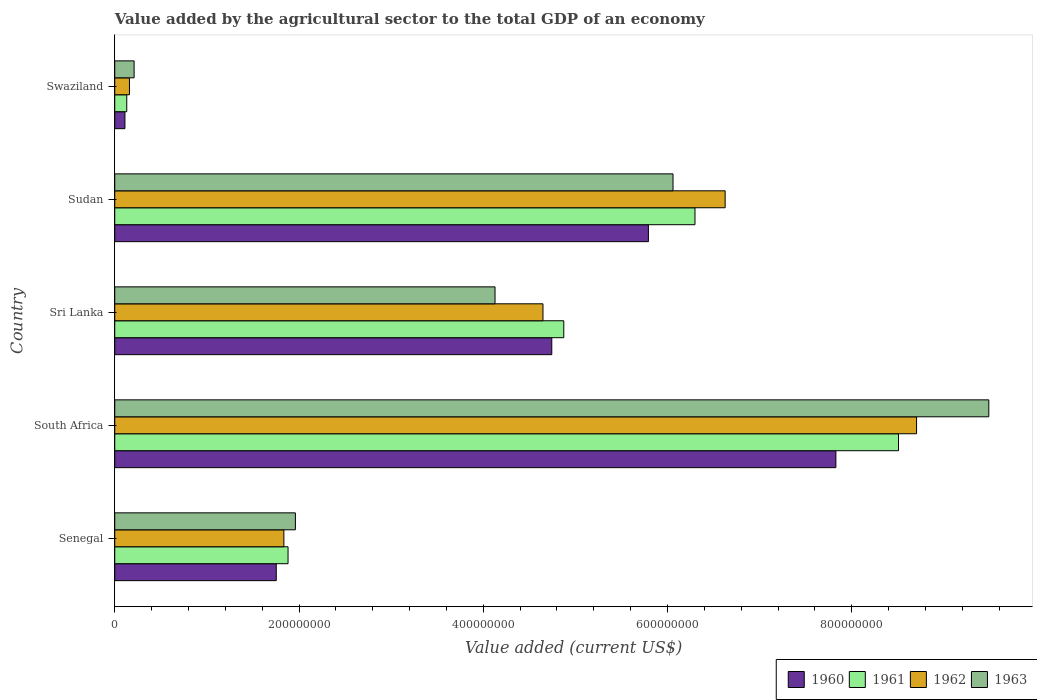How many different coloured bars are there?
Ensure brevity in your answer.  4. How many groups of bars are there?
Offer a terse response. 5. How many bars are there on the 4th tick from the top?
Provide a succinct answer. 4. How many bars are there on the 3rd tick from the bottom?
Your answer should be compact. 4. What is the label of the 5th group of bars from the top?
Keep it short and to the point. Senegal. What is the value added by the agricultural sector to the total GDP in 1963 in Sudan?
Your answer should be compact. 6.06e+08. Across all countries, what is the maximum value added by the agricultural sector to the total GDP in 1960?
Your answer should be very brief. 7.83e+08. Across all countries, what is the minimum value added by the agricultural sector to the total GDP in 1961?
Provide a short and direct response. 1.30e+07. In which country was the value added by the agricultural sector to the total GDP in 1960 maximum?
Your answer should be very brief. South Africa. In which country was the value added by the agricultural sector to the total GDP in 1961 minimum?
Your answer should be compact. Swaziland. What is the total value added by the agricultural sector to the total GDP in 1960 in the graph?
Provide a succinct answer. 2.02e+09. What is the difference between the value added by the agricultural sector to the total GDP in 1962 in Senegal and that in Sri Lanka?
Provide a short and direct response. -2.81e+08. What is the difference between the value added by the agricultural sector to the total GDP in 1962 in Swaziland and the value added by the agricultural sector to the total GDP in 1963 in South Africa?
Ensure brevity in your answer.  -9.33e+08. What is the average value added by the agricultural sector to the total GDP in 1961 per country?
Give a very brief answer. 4.34e+08. What is the difference between the value added by the agricultural sector to the total GDP in 1963 and value added by the agricultural sector to the total GDP in 1961 in Swaziland?
Provide a succinct answer. 7.98e+06. What is the ratio of the value added by the agricultural sector to the total GDP in 1960 in Senegal to that in Swaziland?
Your answer should be very brief. 15.85. Is the difference between the value added by the agricultural sector to the total GDP in 1963 in South Africa and Sudan greater than the difference between the value added by the agricultural sector to the total GDP in 1961 in South Africa and Sudan?
Give a very brief answer. Yes. What is the difference between the highest and the second highest value added by the agricultural sector to the total GDP in 1960?
Your response must be concise. 2.04e+08. What is the difference between the highest and the lowest value added by the agricultural sector to the total GDP in 1960?
Offer a terse response. 7.72e+08. Is it the case that in every country, the sum of the value added by the agricultural sector to the total GDP in 1963 and value added by the agricultural sector to the total GDP in 1960 is greater than the sum of value added by the agricultural sector to the total GDP in 1962 and value added by the agricultural sector to the total GDP in 1961?
Your answer should be compact. No. Are all the bars in the graph horizontal?
Your answer should be very brief. Yes. How many countries are there in the graph?
Your answer should be very brief. 5. Does the graph contain any zero values?
Your answer should be very brief. No. Does the graph contain grids?
Your answer should be compact. No. Where does the legend appear in the graph?
Your answer should be very brief. Bottom right. How are the legend labels stacked?
Your answer should be compact. Horizontal. What is the title of the graph?
Provide a succinct answer. Value added by the agricultural sector to the total GDP of an economy. What is the label or title of the X-axis?
Keep it short and to the point. Value added (current US$). What is the label or title of the Y-axis?
Make the answer very short. Country. What is the Value added (current US$) of 1960 in Senegal?
Ensure brevity in your answer.  1.75e+08. What is the Value added (current US$) in 1961 in Senegal?
Offer a very short reply. 1.88e+08. What is the Value added (current US$) of 1962 in Senegal?
Your response must be concise. 1.84e+08. What is the Value added (current US$) in 1963 in Senegal?
Keep it short and to the point. 1.96e+08. What is the Value added (current US$) in 1960 in South Africa?
Your response must be concise. 7.83e+08. What is the Value added (current US$) in 1961 in South Africa?
Your answer should be compact. 8.51e+08. What is the Value added (current US$) in 1962 in South Africa?
Offer a terse response. 8.70e+08. What is the Value added (current US$) in 1963 in South Africa?
Your answer should be very brief. 9.49e+08. What is the Value added (current US$) in 1960 in Sri Lanka?
Provide a short and direct response. 4.74e+08. What is the Value added (current US$) in 1961 in Sri Lanka?
Your answer should be compact. 4.87e+08. What is the Value added (current US$) of 1962 in Sri Lanka?
Offer a terse response. 4.65e+08. What is the Value added (current US$) in 1963 in Sri Lanka?
Your answer should be compact. 4.13e+08. What is the Value added (current US$) in 1960 in Sudan?
Make the answer very short. 5.79e+08. What is the Value added (current US$) in 1961 in Sudan?
Your answer should be very brief. 6.30e+08. What is the Value added (current US$) in 1962 in Sudan?
Offer a terse response. 6.63e+08. What is the Value added (current US$) of 1963 in Sudan?
Make the answer very short. 6.06e+08. What is the Value added (current US$) of 1960 in Swaziland?
Your response must be concise. 1.11e+07. What is the Value added (current US$) of 1961 in Swaziland?
Provide a succinct answer. 1.30e+07. What is the Value added (current US$) of 1962 in Swaziland?
Offer a terse response. 1.60e+07. What is the Value added (current US$) of 1963 in Swaziland?
Give a very brief answer. 2.10e+07. Across all countries, what is the maximum Value added (current US$) in 1960?
Offer a terse response. 7.83e+08. Across all countries, what is the maximum Value added (current US$) in 1961?
Provide a short and direct response. 8.51e+08. Across all countries, what is the maximum Value added (current US$) of 1962?
Offer a terse response. 8.70e+08. Across all countries, what is the maximum Value added (current US$) of 1963?
Your answer should be compact. 9.49e+08. Across all countries, what is the minimum Value added (current US$) of 1960?
Your response must be concise. 1.11e+07. Across all countries, what is the minimum Value added (current US$) of 1961?
Keep it short and to the point. 1.30e+07. Across all countries, what is the minimum Value added (current US$) of 1962?
Offer a terse response. 1.60e+07. Across all countries, what is the minimum Value added (current US$) of 1963?
Ensure brevity in your answer.  2.10e+07. What is the total Value added (current US$) in 1960 in the graph?
Offer a very short reply. 2.02e+09. What is the total Value added (current US$) of 1961 in the graph?
Provide a short and direct response. 2.17e+09. What is the total Value added (current US$) in 1962 in the graph?
Your response must be concise. 2.20e+09. What is the total Value added (current US$) in 1963 in the graph?
Your answer should be very brief. 2.18e+09. What is the difference between the Value added (current US$) of 1960 in Senegal and that in South Africa?
Your answer should be compact. -6.07e+08. What is the difference between the Value added (current US$) in 1961 in Senegal and that in South Africa?
Offer a terse response. -6.63e+08. What is the difference between the Value added (current US$) in 1962 in Senegal and that in South Africa?
Your response must be concise. -6.87e+08. What is the difference between the Value added (current US$) of 1963 in Senegal and that in South Africa?
Make the answer very short. -7.53e+08. What is the difference between the Value added (current US$) of 1960 in Senegal and that in Sri Lanka?
Give a very brief answer. -2.99e+08. What is the difference between the Value added (current US$) of 1961 in Senegal and that in Sri Lanka?
Your response must be concise. -2.99e+08. What is the difference between the Value added (current US$) in 1962 in Senegal and that in Sri Lanka?
Your response must be concise. -2.81e+08. What is the difference between the Value added (current US$) in 1963 in Senegal and that in Sri Lanka?
Provide a succinct answer. -2.17e+08. What is the difference between the Value added (current US$) in 1960 in Senegal and that in Sudan?
Offer a terse response. -4.04e+08. What is the difference between the Value added (current US$) of 1961 in Senegal and that in Sudan?
Your answer should be compact. -4.42e+08. What is the difference between the Value added (current US$) of 1962 in Senegal and that in Sudan?
Provide a succinct answer. -4.79e+08. What is the difference between the Value added (current US$) of 1963 in Senegal and that in Sudan?
Offer a terse response. -4.10e+08. What is the difference between the Value added (current US$) of 1960 in Senegal and that in Swaziland?
Give a very brief answer. 1.64e+08. What is the difference between the Value added (current US$) of 1961 in Senegal and that in Swaziland?
Offer a very short reply. 1.75e+08. What is the difference between the Value added (current US$) in 1962 in Senegal and that in Swaziland?
Make the answer very short. 1.68e+08. What is the difference between the Value added (current US$) of 1963 in Senegal and that in Swaziland?
Provide a succinct answer. 1.75e+08. What is the difference between the Value added (current US$) in 1960 in South Africa and that in Sri Lanka?
Your answer should be very brief. 3.08e+08. What is the difference between the Value added (current US$) of 1961 in South Africa and that in Sri Lanka?
Your answer should be very brief. 3.63e+08. What is the difference between the Value added (current US$) of 1962 in South Africa and that in Sri Lanka?
Your answer should be compact. 4.06e+08. What is the difference between the Value added (current US$) in 1963 in South Africa and that in Sri Lanka?
Provide a short and direct response. 5.36e+08. What is the difference between the Value added (current US$) of 1960 in South Africa and that in Sudan?
Keep it short and to the point. 2.04e+08. What is the difference between the Value added (current US$) in 1961 in South Africa and that in Sudan?
Your response must be concise. 2.21e+08. What is the difference between the Value added (current US$) in 1962 in South Africa and that in Sudan?
Your answer should be compact. 2.08e+08. What is the difference between the Value added (current US$) in 1963 in South Africa and that in Sudan?
Provide a succinct answer. 3.43e+08. What is the difference between the Value added (current US$) in 1960 in South Africa and that in Swaziland?
Keep it short and to the point. 7.72e+08. What is the difference between the Value added (current US$) of 1961 in South Africa and that in Swaziland?
Keep it short and to the point. 8.38e+08. What is the difference between the Value added (current US$) in 1962 in South Africa and that in Swaziland?
Ensure brevity in your answer.  8.54e+08. What is the difference between the Value added (current US$) in 1963 in South Africa and that in Swaziland?
Offer a very short reply. 9.28e+08. What is the difference between the Value added (current US$) in 1960 in Sri Lanka and that in Sudan?
Make the answer very short. -1.05e+08. What is the difference between the Value added (current US$) of 1961 in Sri Lanka and that in Sudan?
Offer a very short reply. -1.42e+08. What is the difference between the Value added (current US$) of 1962 in Sri Lanka and that in Sudan?
Provide a short and direct response. -1.98e+08. What is the difference between the Value added (current US$) in 1963 in Sri Lanka and that in Sudan?
Give a very brief answer. -1.93e+08. What is the difference between the Value added (current US$) of 1960 in Sri Lanka and that in Swaziland?
Your response must be concise. 4.63e+08. What is the difference between the Value added (current US$) in 1961 in Sri Lanka and that in Swaziland?
Your answer should be compact. 4.74e+08. What is the difference between the Value added (current US$) of 1962 in Sri Lanka and that in Swaziland?
Give a very brief answer. 4.49e+08. What is the difference between the Value added (current US$) in 1963 in Sri Lanka and that in Swaziland?
Provide a succinct answer. 3.92e+08. What is the difference between the Value added (current US$) in 1960 in Sudan and that in Swaziland?
Give a very brief answer. 5.68e+08. What is the difference between the Value added (current US$) in 1961 in Sudan and that in Swaziland?
Keep it short and to the point. 6.17e+08. What is the difference between the Value added (current US$) of 1962 in Sudan and that in Swaziland?
Provide a short and direct response. 6.47e+08. What is the difference between the Value added (current US$) in 1963 in Sudan and that in Swaziland?
Your answer should be compact. 5.85e+08. What is the difference between the Value added (current US$) in 1960 in Senegal and the Value added (current US$) in 1961 in South Africa?
Provide a short and direct response. -6.75e+08. What is the difference between the Value added (current US$) of 1960 in Senegal and the Value added (current US$) of 1962 in South Africa?
Keep it short and to the point. -6.95e+08. What is the difference between the Value added (current US$) of 1960 in Senegal and the Value added (current US$) of 1963 in South Africa?
Your answer should be compact. -7.73e+08. What is the difference between the Value added (current US$) in 1961 in Senegal and the Value added (current US$) in 1962 in South Africa?
Provide a short and direct response. -6.82e+08. What is the difference between the Value added (current US$) of 1961 in Senegal and the Value added (current US$) of 1963 in South Africa?
Ensure brevity in your answer.  -7.61e+08. What is the difference between the Value added (current US$) in 1962 in Senegal and the Value added (current US$) in 1963 in South Africa?
Offer a very short reply. -7.65e+08. What is the difference between the Value added (current US$) of 1960 in Senegal and the Value added (current US$) of 1961 in Sri Lanka?
Make the answer very short. -3.12e+08. What is the difference between the Value added (current US$) of 1960 in Senegal and the Value added (current US$) of 1962 in Sri Lanka?
Your response must be concise. -2.89e+08. What is the difference between the Value added (current US$) in 1960 in Senegal and the Value added (current US$) in 1963 in Sri Lanka?
Make the answer very short. -2.37e+08. What is the difference between the Value added (current US$) of 1961 in Senegal and the Value added (current US$) of 1962 in Sri Lanka?
Keep it short and to the point. -2.77e+08. What is the difference between the Value added (current US$) of 1961 in Senegal and the Value added (current US$) of 1963 in Sri Lanka?
Ensure brevity in your answer.  -2.25e+08. What is the difference between the Value added (current US$) in 1962 in Senegal and the Value added (current US$) in 1963 in Sri Lanka?
Offer a terse response. -2.29e+08. What is the difference between the Value added (current US$) of 1960 in Senegal and the Value added (current US$) of 1961 in Sudan?
Give a very brief answer. -4.54e+08. What is the difference between the Value added (current US$) of 1960 in Senegal and the Value added (current US$) of 1962 in Sudan?
Make the answer very short. -4.87e+08. What is the difference between the Value added (current US$) in 1960 in Senegal and the Value added (current US$) in 1963 in Sudan?
Your answer should be compact. -4.31e+08. What is the difference between the Value added (current US$) of 1961 in Senegal and the Value added (current US$) of 1962 in Sudan?
Your answer should be very brief. -4.74e+08. What is the difference between the Value added (current US$) in 1961 in Senegal and the Value added (current US$) in 1963 in Sudan?
Make the answer very short. -4.18e+08. What is the difference between the Value added (current US$) in 1962 in Senegal and the Value added (current US$) in 1963 in Sudan?
Offer a terse response. -4.22e+08. What is the difference between the Value added (current US$) in 1960 in Senegal and the Value added (current US$) in 1961 in Swaziland?
Provide a succinct answer. 1.62e+08. What is the difference between the Value added (current US$) in 1960 in Senegal and the Value added (current US$) in 1962 in Swaziland?
Ensure brevity in your answer.  1.59e+08. What is the difference between the Value added (current US$) of 1960 in Senegal and the Value added (current US$) of 1963 in Swaziland?
Make the answer very short. 1.54e+08. What is the difference between the Value added (current US$) of 1961 in Senegal and the Value added (current US$) of 1962 in Swaziland?
Keep it short and to the point. 1.72e+08. What is the difference between the Value added (current US$) in 1961 in Senegal and the Value added (current US$) in 1963 in Swaziland?
Offer a terse response. 1.67e+08. What is the difference between the Value added (current US$) of 1962 in Senegal and the Value added (current US$) of 1963 in Swaziland?
Provide a succinct answer. 1.63e+08. What is the difference between the Value added (current US$) of 1960 in South Africa and the Value added (current US$) of 1961 in Sri Lanka?
Ensure brevity in your answer.  2.95e+08. What is the difference between the Value added (current US$) in 1960 in South Africa and the Value added (current US$) in 1962 in Sri Lanka?
Provide a succinct answer. 3.18e+08. What is the difference between the Value added (current US$) of 1960 in South Africa and the Value added (current US$) of 1963 in Sri Lanka?
Your response must be concise. 3.70e+08. What is the difference between the Value added (current US$) of 1961 in South Africa and the Value added (current US$) of 1962 in Sri Lanka?
Provide a succinct answer. 3.86e+08. What is the difference between the Value added (current US$) of 1961 in South Africa and the Value added (current US$) of 1963 in Sri Lanka?
Provide a short and direct response. 4.38e+08. What is the difference between the Value added (current US$) of 1962 in South Africa and the Value added (current US$) of 1963 in Sri Lanka?
Provide a succinct answer. 4.58e+08. What is the difference between the Value added (current US$) of 1960 in South Africa and the Value added (current US$) of 1961 in Sudan?
Provide a succinct answer. 1.53e+08. What is the difference between the Value added (current US$) of 1960 in South Africa and the Value added (current US$) of 1962 in Sudan?
Provide a succinct answer. 1.20e+08. What is the difference between the Value added (current US$) of 1960 in South Africa and the Value added (current US$) of 1963 in Sudan?
Give a very brief answer. 1.77e+08. What is the difference between the Value added (current US$) in 1961 in South Africa and the Value added (current US$) in 1962 in Sudan?
Ensure brevity in your answer.  1.88e+08. What is the difference between the Value added (current US$) in 1961 in South Africa and the Value added (current US$) in 1963 in Sudan?
Give a very brief answer. 2.45e+08. What is the difference between the Value added (current US$) of 1962 in South Africa and the Value added (current US$) of 1963 in Sudan?
Your answer should be compact. 2.64e+08. What is the difference between the Value added (current US$) in 1960 in South Africa and the Value added (current US$) in 1961 in Swaziland?
Your answer should be very brief. 7.70e+08. What is the difference between the Value added (current US$) of 1960 in South Africa and the Value added (current US$) of 1962 in Swaziland?
Offer a very short reply. 7.67e+08. What is the difference between the Value added (current US$) in 1960 in South Africa and the Value added (current US$) in 1963 in Swaziland?
Offer a terse response. 7.62e+08. What is the difference between the Value added (current US$) of 1961 in South Africa and the Value added (current US$) of 1962 in Swaziland?
Your answer should be compact. 8.35e+08. What is the difference between the Value added (current US$) in 1961 in South Africa and the Value added (current US$) in 1963 in Swaziland?
Your response must be concise. 8.30e+08. What is the difference between the Value added (current US$) of 1962 in South Africa and the Value added (current US$) of 1963 in Swaziland?
Keep it short and to the point. 8.49e+08. What is the difference between the Value added (current US$) of 1960 in Sri Lanka and the Value added (current US$) of 1961 in Sudan?
Make the answer very short. -1.55e+08. What is the difference between the Value added (current US$) of 1960 in Sri Lanka and the Value added (current US$) of 1962 in Sudan?
Your answer should be very brief. -1.88e+08. What is the difference between the Value added (current US$) of 1960 in Sri Lanka and the Value added (current US$) of 1963 in Sudan?
Provide a succinct answer. -1.32e+08. What is the difference between the Value added (current US$) of 1961 in Sri Lanka and the Value added (current US$) of 1962 in Sudan?
Ensure brevity in your answer.  -1.75e+08. What is the difference between the Value added (current US$) of 1961 in Sri Lanka and the Value added (current US$) of 1963 in Sudan?
Keep it short and to the point. -1.19e+08. What is the difference between the Value added (current US$) in 1962 in Sri Lanka and the Value added (current US$) in 1963 in Sudan?
Ensure brevity in your answer.  -1.41e+08. What is the difference between the Value added (current US$) in 1960 in Sri Lanka and the Value added (current US$) in 1961 in Swaziland?
Offer a very short reply. 4.61e+08. What is the difference between the Value added (current US$) in 1960 in Sri Lanka and the Value added (current US$) in 1962 in Swaziland?
Offer a very short reply. 4.58e+08. What is the difference between the Value added (current US$) of 1960 in Sri Lanka and the Value added (current US$) of 1963 in Swaziland?
Your response must be concise. 4.53e+08. What is the difference between the Value added (current US$) of 1961 in Sri Lanka and the Value added (current US$) of 1962 in Swaziland?
Your answer should be very brief. 4.71e+08. What is the difference between the Value added (current US$) of 1961 in Sri Lanka and the Value added (current US$) of 1963 in Swaziland?
Your answer should be very brief. 4.66e+08. What is the difference between the Value added (current US$) in 1962 in Sri Lanka and the Value added (current US$) in 1963 in Swaziland?
Make the answer very short. 4.44e+08. What is the difference between the Value added (current US$) of 1960 in Sudan and the Value added (current US$) of 1961 in Swaziland?
Keep it short and to the point. 5.66e+08. What is the difference between the Value added (current US$) in 1960 in Sudan and the Value added (current US$) in 1962 in Swaziland?
Provide a short and direct response. 5.63e+08. What is the difference between the Value added (current US$) in 1960 in Sudan and the Value added (current US$) in 1963 in Swaziland?
Provide a succinct answer. 5.58e+08. What is the difference between the Value added (current US$) of 1961 in Sudan and the Value added (current US$) of 1962 in Swaziland?
Give a very brief answer. 6.14e+08. What is the difference between the Value added (current US$) of 1961 in Sudan and the Value added (current US$) of 1963 in Swaziland?
Offer a terse response. 6.09e+08. What is the difference between the Value added (current US$) in 1962 in Sudan and the Value added (current US$) in 1963 in Swaziland?
Provide a succinct answer. 6.42e+08. What is the average Value added (current US$) of 1960 per country?
Make the answer very short. 4.05e+08. What is the average Value added (current US$) in 1961 per country?
Your answer should be compact. 4.34e+08. What is the average Value added (current US$) in 1962 per country?
Your answer should be very brief. 4.39e+08. What is the average Value added (current US$) of 1963 per country?
Offer a very short reply. 4.37e+08. What is the difference between the Value added (current US$) of 1960 and Value added (current US$) of 1961 in Senegal?
Your answer should be compact. -1.28e+07. What is the difference between the Value added (current US$) in 1960 and Value added (current US$) in 1962 in Senegal?
Provide a short and direct response. -8.24e+06. What is the difference between the Value added (current US$) in 1960 and Value added (current US$) in 1963 in Senegal?
Your answer should be very brief. -2.07e+07. What is the difference between the Value added (current US$) in 1961 and Value added (current US$) in 1962 in Senegal?
Give a very brief answer. 4.54e+06. What is the difference between the Value added (current US$) of 1961 and Value added (current US$) of 1963 in Senegal?
Make the answer very short. -7.96e+06. What is the difference between the Value added (current US$) of 1962 and Value added (current US$) of 1963 in Senegal?
Give a very brief answer. -1.25e+07. What is the difference between the Value added (current US$) of 1960 and Value added (current US$) of 1961 in South Africa?
Make the answer very short. -6.80e+07. What is the difference between the Value added (current US$) of 1960 and Value added (current US$) of 1962 in South Africa?
Offer a very short reply. -8.76e+07. What is the difference between the Value added (current US$) in 1960 and Value added (current US$) in 1963 in South Africa?
Your answer should be compact. -1.66e+08. What is the difference between the Value added (current US$) of 1961 and Value added (current US$) of 1962 in South Africa?
Make the answer very short. -1.96e+07. What is the difference between the Value added (current US$) in 1961 and Value added (current US$) in 1963 in South Africa?
Your answer should be very brief. -9.80e+07. What is the difference between the Value added (current US$) in 1962 and Value added (current US$) in 1963 in South Africa?
Your response must be concise. -7.84e+07. What is the difference between the Value added (current US$) in 1960 and Value added (current US$) in 1961 in Sri Lanka?
Your answer should be very brief. -1.30e+07. What is the difference between the Value added (current US$) in 1960 and Value added (current US$) in 1962 in Sri Lanka?
Ensure brevity in your answer.  9.55e+06. What is the difference between the Value added (current US$) of 1960 and Value added (current US$) of 1963 in Sri Lanka?
Provide a succinct answer. 6.16e+07. What is the difference between the Value added (current US$) in 1961 and Value added (current US$) in 1962 in Sri Lanka?
Keep it short and to the point. 2.26e+07. What is the difference between the Value added (current US$) of 1961 and Value added (current US$) of 1963 in Sri Lanka?
Ensure brevity in your answer.  7.46e+07. What is the difference between the Value added (current US$) in 1962 and Value added (current US$) in 1963 in Sri Lanka?
Make the answer very short. 5.20e+07. What is the difference between the Value added (current US$) of 1960 and Value added (current US$) of 1961 in Sudan?
Your answer should be very brief. -5.05e+07. What is the difference between the Value added (current US$) in 1960 and Value added (current US$) in 1962 in Sudan?
Your answer should be very brief. -8.33e+07. What is the difference between the Value added (current US$) in 1960 and Value added (current US$) in 1963 in Sudan?
Your answer should be compact. -2.67e+07. What is the difference between the Value added (current US$) in 1961 and Value added (current US$) in 1962 in Sudan?
Give a very brief answer. -3.27e+07. What is the difference between the Value added (current US$) in 1961 and Value added (current US$) in 1963 in Sudan?
Make the answer very short. 2.38e+07. What is the difference between the Value added (current US$) in 1962 and Value added (current US$) in 1963 in Sudan?
Keep it short and to the point. 5.66e+07. What is the difference between the Value added (current US$) of 1960 and Value added (current US$) of 1961 in Swaziland?
Your answer should be compact. -1.96e+06. What is the difference between the Value added (current US$) in 1960 and Value added (current US$) in 1962 in Swaziland?
Provide a short and direct response. -4.90e+06. What is the difference between the Value added (current US$) in 1960 and Value added (current US$) in 1963 in Swaziland?
Offer a very short reply. -9.94e+06. What is the difference between the Value added (current US$) of 1961 and Value added (current US$) of 1962 in Swaziland?
Offer a very short reply. -2.94e+06. What is the difference between the Value added (current US$) of 1961 and Value added (current US$) of 1963 in Swaziland?
Make the answer very short. -7.98e+06. What is the difference between the Value added (current US$) of 1962 and Value added (current US$) of 1963 in Swaziland?
Offer a very short reply. -5.04e+06. What is the ratio of the Value added (current US$) in 1960 in Senegal to that in South Africa?
Your response must be concise. 0.22. What is the ratio of the Value added (current US$) of 1961 in Senegal to that in South Africa?
Offer a terse response. 0.22. What is the ratio of the Value added (current US$) in 1962 in Senegal to that in South Africa?
Offer a terse response. 0.21. What is the ratio of the Value added (current US$) in 1963 in Senegal to that in South Africa?
Keep it short and to the point. 0.21. What is the ratio of the Value added (current US$) in 1960 in Senegal to that in Sri Lanka?
Ensure brevity in your answer.  0.37. What is the ratio of the Value added (current US$) in 1961 in Senegal to that in Sri Lanka?
Your answer should be very brief. 0.39. What is the ratio of the Value added (current US$) of 1962 in Senegal to that in Sri Lanka?
Your answer should be compact. 0.39. What is the ratio of the Value added (current US$) in 1963 in Senegal to that in Sri Lanka?
Keep it short and to the point. 0.47. What is the ratio of the Value added (current US$) of 1960 in Senegal to that in Sudan?
Offer a terse response. 0.3. What is the ratio of the Value added (current US$) in 1961 in Senegal to that in Sudan?
Offer a terse response. 0.3. What is the ratio of the Value added (current US$) in 1962 in Senegal to that in Sudan?
Make the answer very short. 0.28. What is the ratio of the Value added (current US$) of 1963 in Senegal to that in Sudan?
Ensure brevity in your answer.  0.32. What is the ratio of the Value added (current US$) of 1960 in Senegal to that in Swaziland?
Offer a very short reply. 15.85. What is the ratio of the Value added (current US$) of 1961 in Senegal to that in Swaziland?
Keep it short and to the point. 14.45. What is the ratio of the Value added (current US$) in 1962 in Senegal to that in Swaziland?
Provide a succinct answer. 11.5. What is the ratio of the Value added (current US$) of 1963 in Senegal to that in Swaziland?
Ensure brevity in your answer.  9.34. What is the ratio of the Value added (current US$) of 1960 in South Africa to that in Sri Lanka?
Your answer should be very brief. 1.65. What is the ratio of the Value added (current US$) of 1961 in South Africa to that in Sri Lanka?
Your answer should be compact. 1.75. What is the ratio of the Value added (current US$) of 1962 in South Africa to that in Sri Lanka?
Keep it short and to the point. 1.87. What is the ratio of the Value added (current US$) of 1963 in South Africa to that in Sri Lanka?
Ensure brevity in your answer.  2.3. What is the ratio of the Value added (current US$) of 1960 in South Africa to that in Sudan?
Provide a succinct answer. 1.35. What is the ratio of the Value added (current US$) in 1961 in South Africa to that in Sudan?
Offer a terse response. 1.35. What is the ratio of the Value added (current US$) in 1962 in South Africa to that in Sudan?
Your answer should be very brief. 1.31. What is the ratio of the Value added (current US$) of 1963 in South Africa to that in Sudan?
Your answer should be compact. 1.57. What is the ratio of the Value added (current US$) in 1960 in South Africa to that in Swaziland?
Provide a succinct answer. 70.77. What is the ratio of the Value added (current US$) in 1961 in South Africa to that in Swaziland?
Provide a succinct answer. 65.34. What is the ratio of the Value added (current US$) of 1962 in South Africa to that in Swaziland?
Your answer should be very brief. 54.53. What is the ratio of the Value added (current US$) in 1963 in South Africa to that in Swaziland?
Provide a short and direct response. 45.18. What is the ratio of the Value added (current US$) of 1960 in Sri Lanka to that in Sudan?
Ensure brevity in your answer.  0.82. What is the ratio of the Value added (current US$) in 1961 in Sri Lanka to that in Sudan?
Your answer should be very brief. 0.77. What is the ratio of the Value added (current US$) in 1962 in Sri Lanka to that in Sudan?
Ensure brevity in your answer.  0.7. What is the ratio of the Value added (current US$) of 1963 in Sri Lanka to that in Sudan?
Offer a very short reply. 0.68. What is the ratio of the Value added (current US$) of 1960 in Sri Lanka to that in Swaziland?
Your answer should be very brief. 42.89. What is the ratio of the Value added (current US$) in 1961 in Sri Lanka to that in Swaziland?
Offer a terse response. 37.43. What is the ratio of the Value added (current US$) in 1962 in Sri Lanka to that in Swaziland?
Your answer should be compact. 29.12. What is the ratio of the Value added (current US$) of 1963 in Sri Lanka to that in Swaziland?
Provide a succinct answer. 19.66. What is the ratio of the Value added (current US$) in 1960 in Sudan to that in Swaziland?
Offer a terse response. 52.37. What is the ratio of the Value added (current US$) of 1961 in Sudan to that in Swaziland?
Offer a very short reply. 48.37. What is the ratio of the Value added (current US$) of 1962 in Sudan to that in Swaziland?
Give a very brief answer. 41.51. What is the ratio of the Value added (current US$) of 1963 in Sudan to that in Swaziland?
Ensure brevity in your answer.  28.86. What is the difference between the highest and the second highest Value added (current US$) in 1960?
Provide a succinct answer. 2.04e+08. What is the difference between the highest and the second highest Value added (current US$) of 1961?
Provide a short and direct response. 2.21e+08. What is the difference between the highest and the second highest Value added (current US$) of 1962?
Make the answer very short. 2.08e+08. What is the difference between the highest and the second highest Value added (current US$) of 1963?
Your answer should be very brief. 3.43e+08. What is the difference between the highest and the lowest Value added (current US$) in 1960?
Ensure brevity in your answer.  7.72e+08. What is the difference between the highest and the lowest Value added (current US$) in 1961?
Ensure brevity in your answer.  8.38e+08. What is the difference between the highest and the lowest Value added (current US$) in 1962?
Offer a very short reply. 8.54e+08. What is the difference between the highest and the lowest Value added (current US$) in 1963?
Your response must be concise. 9.28e+08. 